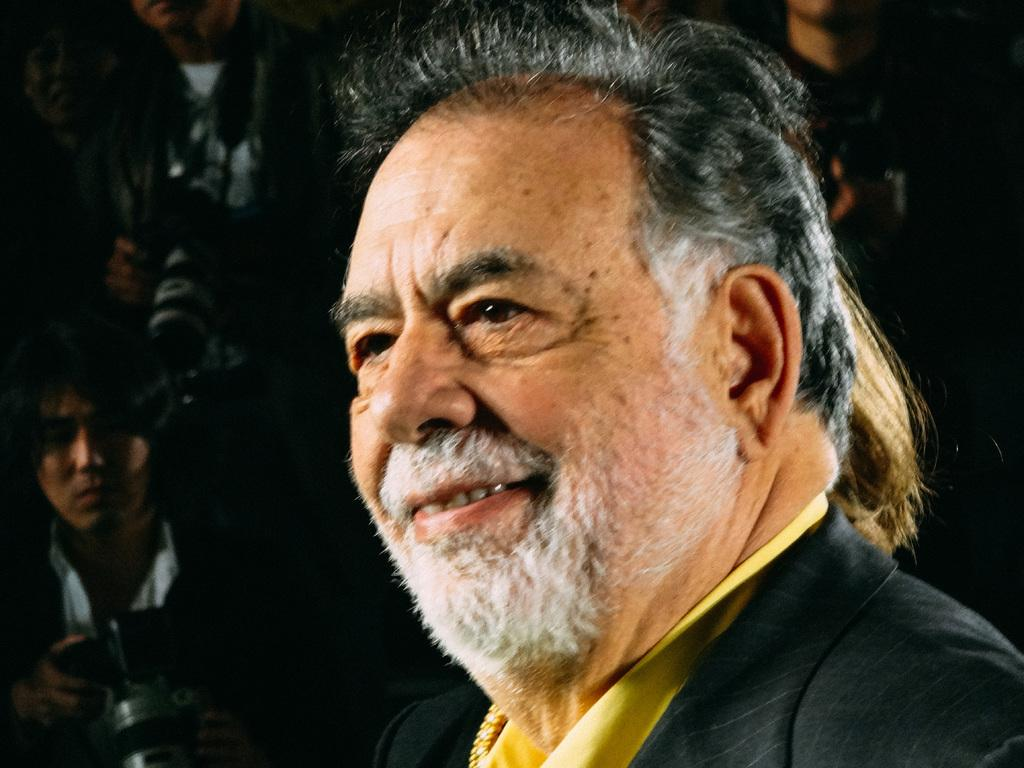What is the main subject of the image? There is a person in the image. How is the person's facial expression? The person has a smile on his face. Are there any other people in the image? Yes, there are other people behind the person. What might one of the people be doing? One of the people is holding a camera in his hand. What type of sock can be seen hanging in the wind in the image? There is no sock or wind present in the image. 